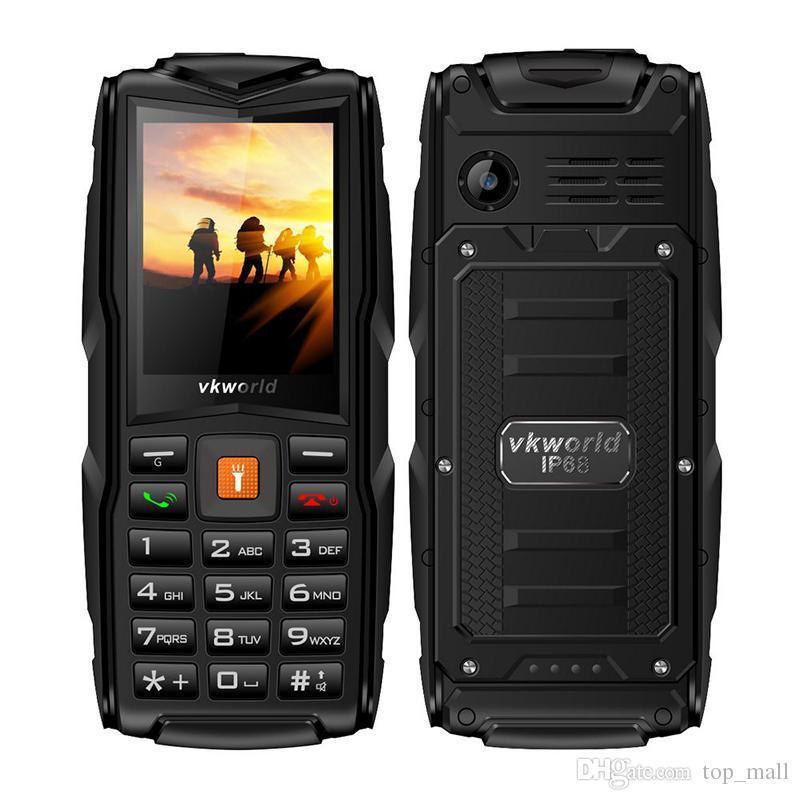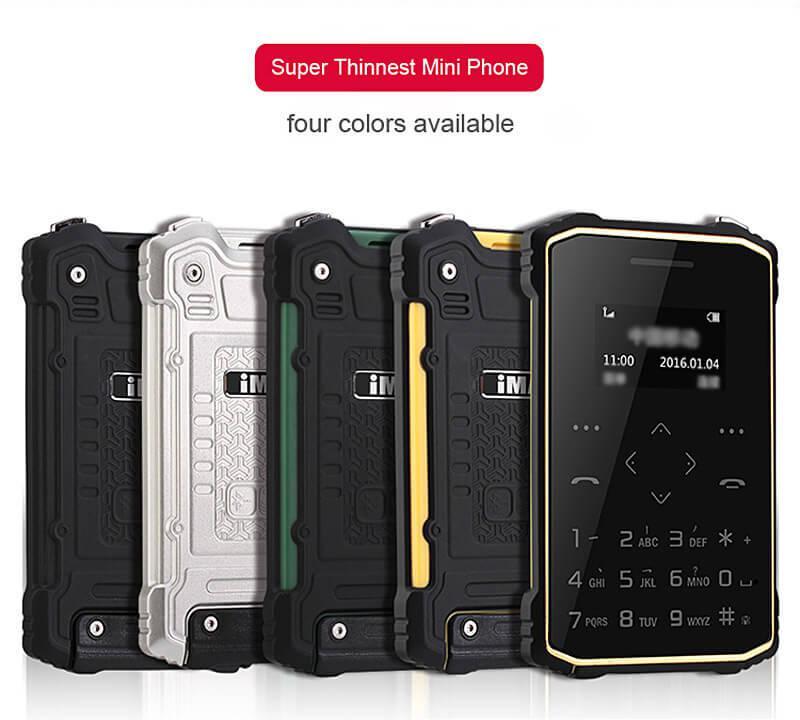The first image is the image on the left, the second image is the image on the right. Given the left and right images, does the statement "The right image features a profile orientation of the phone." hold true? Answer yes or no. No. 